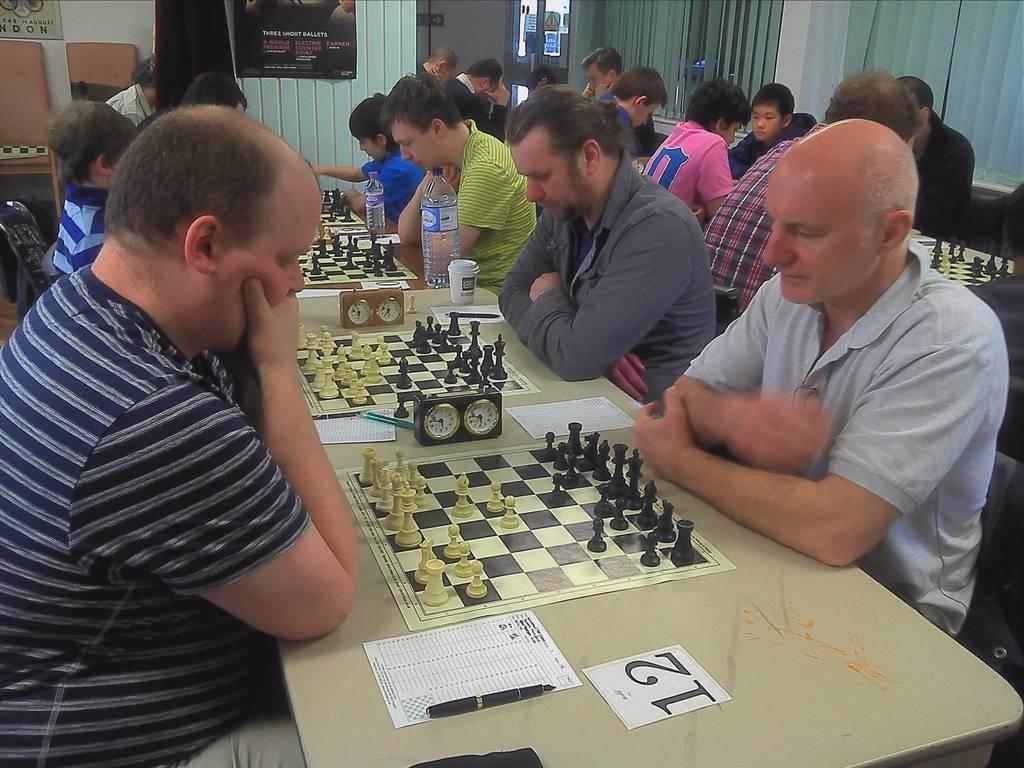How would you summarize this image in a sentence or two? In this picture I can see group of people are sitting in front of a table. On the table I can see chess boards, bottles, glasses, clocks and other objects. In the wall and other objects. 